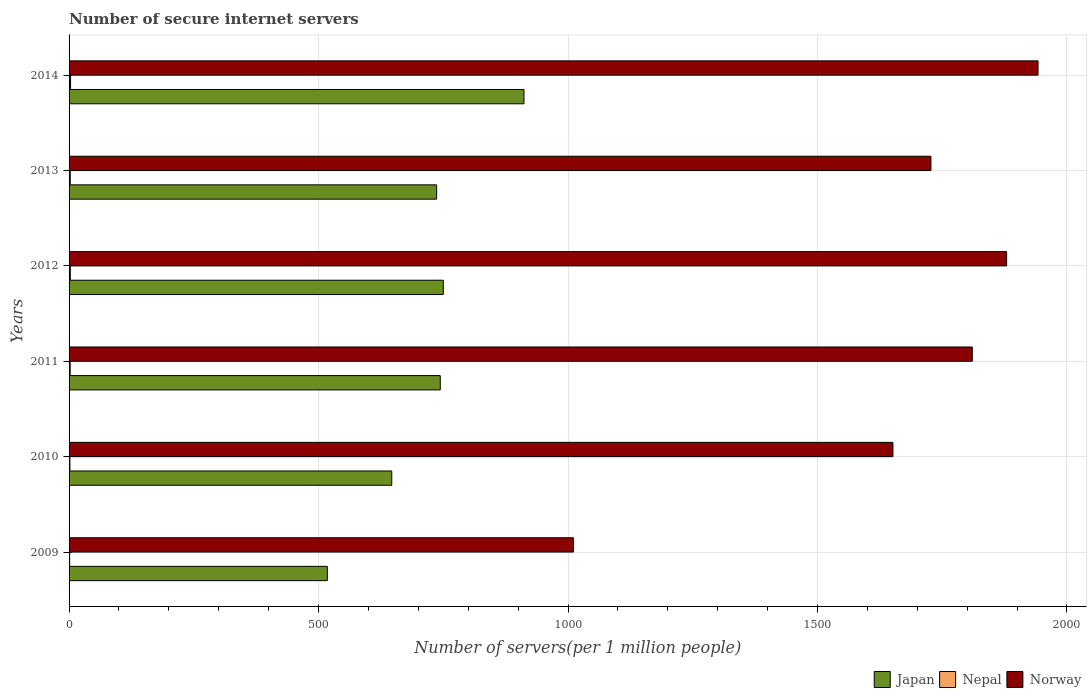Are the number of bars per tick equal to the number of legend labels?
Give a very brief answer. Yes. Are the number of bars on each tick of the Y-axis equal?
Provide a short and direct response. Yes. What is the label of the 3rd group of bars from the top?
Your response must be concise. 2012. What is the number of secure internet servers in Japan in 2012?
Give a very brief answer. 750.05. Across all years, what is the maximum number of secure internet servers in Norway?
Offer a terse response. 1941.99. Across all years, what is the minimum number of secure internet servers in Nepal?
Keep it short and to the point. 1.17. What is the total number of secure internet servers in Japan in the graph?
Your response must be concise. 4306.64. What is the difference between the number of secure internet servers in Nepal in 2009 and that in 2014?
Your answer should be very brief. -1.82. What is the difference between the number of secure internet servers in Norway in 2014 and the number of secure internet servers in Nepal in 2012?
Give a very brief answer. 1939.52. What is the average number of secure internet servers in Japan per year?
Keep it short and to the point. 717.77. In the year 2013, what is the difference between the number of secure internet servers in Norway and number of secure internet servers in Nepal?
Ensure brevity in your answer.  1724.92. What is the ratio of the number of secure internet servers in Nepal in 2013 to that in 2014?
Your answer should be compact. 0.8. Is the number of secure internet servers in Japan in 2009 less than that in 2010?
Your answer should be compact. Yes. Is the difference between the number of secure internet servers in Norway in 2009 and 2010 greater than the difference between the number of secure internet servers in Nepal in 2009 and 2010?
Your answer should be very brief. No. What is the difference between the highest and the second highest number of secure internet servers in Norway?
Make the answer very short. 62.97. What is the difference between the highest and the lowest number of secure internet servers in Nepal?
Your answer should be compact. 1.82. In how many years, is the number of secure internet servers in Japan greater than the average number of secure internet servers in Japan taken over all years?
Offer a very short reply. 4. What does the 2nd bar from the bottom in 2012 represents?
Give a very brief answer. Nepal. Is it the case that in every year, the sum of the number of secure internet servers in Norway and number of secure internet servers in Japan is greater than the number of secure internet servers in Nepal?
Your response must be concise. Yes. How many bars are there?
Your answer should be very brief. 18. Are all the bars in the graph horizontal?
Ensure brevity in your answer.  Yes. How many years are there in the graph?
Give a very brief answer. 6. Are the values on the major ticks of X-axis written in scientific E-notation?
Your response must be concise. No. Does the graph contain any zero values?
Make the answer very short. No. How are the legend labels stacked?
Provide a succinct answer. Horizontal. What is the title of the graph?
Give a very brief answer. Number of secure internet servers. Does "Trinidad and Tobago" appear as one of the legend labels in the graph?
Make the answer very short. No. What is the label or title of the X-axis?
Make the answer very short. Number of servers(per 1 million people). What is the label or title of the Y-axis?
Keep it short and to the point. Years. What is the Number of servers(per 1 million people) of Japan in 2009?
Give a very brief answer. 517.61. What is the Number of servers(per 1 million people) of Nepal in 2009?
Provide a succinct answer. 1.17. What is the Number of servers(per 1 million people) of Norway in 2009?
Your response must be concise. 1010.83. What is the Number of servers(per 1 million people) in Japan in 2010?
Ensure brevity in your answer.  646.7. What is the Number of servers(per 1 million people) of Nepal in 2010?
Ensure brevity in your answer.  1.67. What is the Number of servers(per 1 million people) of Norway in 2010?
Your answer should be compact. 1651.17. What is the Number of servers(per 1 million people) in Japan in 2011?
Make the answer very short. 743.93. What is the Number of servers(per 1 million people) in Nepal in 2011?
Your response must be concise. 2.17. What is the Number of servers(per 1 million people) in Norway in 2011?
Ensure brevity in your answer.  1810.18. What is the Number of servers(per 1 million people) in Japan in 2012?
Ensure brevity in your answer.  750.05. What is the Number of servers(per 1 million people) in Nepal in 2012?
Offer a terse response. 2.47. What is the Number of servers(per 1 million people) of Norway in 2012?
Your response must be concise. 1879.02. What is the Number of servers(per 1 million people) in Japan in 2013?
Provide a succinct answer. 736.67. What is the Number of servers(per 1 million people) of Nepal in 2013?
Your response must be concise. 2.37. What is the Number of servers(per 1 million people) in Norway in 2013?
Keep it short and to the point. 1727.29. What is the Number of servers(per 1 million people) in Japan in 2014?
Your answer should be compact. 911.68. What is the Number of servers(per 1 million people) of Nepal in 2014?
Give a very brief answer. 2.98. What is the Number of servers(per 1 million people) in Norway in 2014?
Offer a terse response. 1941.99. Across all years, what is the maximum Number of servers(per 1 million people) in Japan?
Provide a succinct answer. 911.68. Across all years, what is the maximum Number of servers(per 1 million people) in Nepal?
Offer a terse response. 2.98. Across all years, what is the maximum Number of servers(per 1 million people) of Norway?
Make the answer very short. 1941.99. Across all years, what is the minimum Number of servers(per 1 million people) of Japan?
Provide a succinct answer. 517.61. Across all years, what is the minimum Number of servers(per 1 million people) of Nepal?
Keep it short and to the point. 1.17. Across all years, what is the minimum Number of servers(per 1 million people) in Norway?
Keep it short and to the point. 1010.83. What is the total Number of servers(per 1 million people) of Japan in the graph?
Make the answer very short. 4306.64. What is the total Number of servers(per 1 million people) of Nepal in the graph?
Make the answer very short. 12.84. What is the total Number of servers(per 1 million people) of Norway in the graph?
Offer a terse response. 1.00e+04. What is the difference between the Number of servers(per 1 million people) of Japan in 2009 and that in 2010?
Offer a terse response. -129.09. What is the difference between the Number of servers(per 1 million people) in Nepal in 2009 and that in 2010?
Your answer should be very brief. -0.51. What is the difference between the Number of servers(per 1 million people) of Norway in 2009 and that in 2010?
Provide a short and direct response. -640.35. What is the difference between the Number of servers(per 1 million people) of Japan in 2009 and that in 2011?
Ensure brevity in your answer.  -226.31. What is the difference between the Number of servers(per 1 million people) of Nepal in 2009 and that in 2011?
Ensure brevity in your answer.  -1. What is the difference between the Number of servers(per 1 million people) of Norway in 2009 and that in 2011?
Offer a very short reply. -799.36. What is the difference between the Number of servers(per 1 million people) of Japan in 2009 and that in 2012?
Your response must be concise. -232.43. What is the difference between the Number of servers(per 1 million people) of Nepal in 2009 and that in 2012?
Make the answer very short. -1.31. What is the difference between the Number of servers(per 1 million people) in Norway in 2009 and that in 2012?
Ensure brevity in your answer.  -868.19. What is the difference between the Number of servers(per 1 million people) of Japan in 2009 and that in 2013?
Give a very brief answer. -219.05. What is the difference between the Number of servers(per 1 million people) in Nepal in 2009 and that in 2013?
Keep it short and to the point. -1.21. What is the difference between the Number of servers(per 1 million people) of Norway in 2009 and that in 2013?
Keep it short and to the point. -716.47. What is the difference between the Number of servers(per 1 million people) of Japan in 2009 and that in 2014?
Keep it short and to the point. -394.07. What is the difference between the Number of servers(per 1 million people) in Nepal in 2009 and that in 2014?
Keep it short and to the point. -1.82. What is the difference between the Number of servers(per 1 million people) in Norway in 2009 and that in 2014?
Offer a very short reply. -931.17. What is the difference between the Number of servers(per 1 million people) of Japan in 2010 and that in 2011?
Offer a very short reply. -97.23. What is the difference between the Number of servers(per 1 million people) of Nepal in 2010 and that in 2011?
Offer a terse response. -0.5. What is the difference between the Number of servers(per 1 million people) in Norway in 2010 and that in 2011?
Offer a very short reply. -159.01. What is the difference between the Number of servers(per 1 million people) in Japan in 2010 and that in 2012?
Provide a short and direct response. -103.35. What is the difference between the Number of servers(per 1 million people) of Nepal in 2010 and that in 2012?
Make the answer very short. -0.8. What is the difference between the Number of servers(per 1 million people) in Norway in 2010 and that in 2012?
Give a very brief answer. -227.85. What is the difference between the Number of servers(per 1 million people) of Japan in 2010 and that in 2013?
Provide a succinct answer. -89.96. What is the difference between the Number of servers(per 1 million people) in Nepal in 2010 and that in 2013?
Offer a terse response. -0.7. What is the difference between the Number of servers(per 1 million people) of Norway in 2010 and that in 2013?
Give a very brief answer. -76.12. What is the difference between the Number of servers(per 1 million people) of Japan in 2010 and that in 2014?
Provide a succinct answer. -264.98. What is the difference between the Number of servers(per 1 million people) in Nepal in 2010 and that in 2014?
Your answer should be compact. -1.31. What is the difference between the Number of servers(per 1 million people) of Norway in 2010 and that in 2014?
Give a very brief answer. -290.82. What is the difference between the Number of servers(per 1 million people) in Japan in 2011 and that in 2012?
Give a very brief answer. -6.12. What is the difference between the Number of servers(per 1 million people) in Nepal in 2011 and that in 2012?
Offer a terse response. -0.3. What is the difference between the Number of servers(per 1 million people) of Norway in 2011 and that in 2012?
Your answer should be compact. -68.84. What is the difference between the Number of servers(per 1 million people) of Japan in 2011 and that in 2013?
Offer a very short reply. 7.26. What is the difference between the Number of servers(per 1 million people) of Nepal in 2011 and that in 2013?
Offer a terse response. -0.2. What is the difference between the Number of servers(per 1 million people) of Norway in 2011 and that in 2013?
Your answer should be very brief. 82.89. What is the difference between the Number of servers(per 1 million people) of Japan in 2011 and that in 2014?
Make the answer very short. -167.75. What is the difference between the Number of servers(per 1 million people) of Nepal in 2011 and that in 2014?
Your answer should be very brief. -0.81. What is the difference between the Number of servers(per 1 million people) in Norway in 2011 and that in 2014?
Keep it short and to the point. -131.81. What is the difference between the Number of servers(per 1 million people) in Japan in 2012 and that in 2013?
Offer a terse response. 13.38. What is the difference between the Number of servers(per 1 million people) of Nepal in 2012 and that in 2013?
Make the answer very short. 0.1. What is the difference between the Number of servers(per 1 million people) in Norway in 2012 and that in 2013?
Give a very brief answer. 151.73. What is the difference between the Number of servers(per 1 million people) in Japan in 2012 and that in 2014?
Ensure brevity in your answer.  -161.64. What is the difference between the Number of servers(per 1 million people) in Nepal in 2012 and that in 2014?
Keep it short and to the point. -0.51. What is the difference between the Number of servers(per 1 million people) in Norway in 2012 and that in 2014?
Your response must be concise. -62.97. What is the difference between the Number of servers(per 1 million people) of Japan in 2013 and that in 2014?
Provide a short and direct response. -175.02. What is the difference between the Number of servers(per 1 million people) of Nepal in 2013 and that in 2014?
Provide a short and direct response. -0.61. What is the difference between the Number of servers(per 1 million people) of Norway in 2013 and that in 2014?
Make the answer very short. -214.7. What is the difference between the Number of servers(per 1 million people) of Japan in 2009 and the Number of servers(per 1 million people) of Nepal in 2010?
Provide a short and direct response. 515.94. What is the difference between the Number of servers(per 1 million people) of Japan in 2009 and the Number of servers(per 1 million people) of Norway in 2010?
Your answer should be compact. -1133.56. What is the difference between the Number of servers(per 1 million people) in Nepal in 2009 and the Number of servers(per 1 million people) in Norway in 2010?
Your answer should be compact. -1650.01. What is the difference between the Number of servers(per 1 million people) in Japan in 2009 and the Number of servers(per 1 million people) in Nepal in 2011?
Keep it short and to the point. 515.44. What is the difference between the Number of servers(per 1 million people) of Japan in 2009 and the Number of servers(per 1 million people) of Norway in 2011?
Your response must be concise. -1292.57. What is the difference between the Number of servers(per 1 million people) in Nepal in 2009 and the Number of servers(per 1 million people) in Norway in 2011?
Your response must be concise. -1809.02. What is the difference between the Number of servers(per 1 million people) in Japan in 2009 and the Number of servers(per 1 million people) in Nepal in 2012?
Give a very brief answer. 515.14. What is the difference between the Number of servers(per 1 million people) of Japan in 2009 and the Number of servers(per 1 million people) of Norway in 2012?
Ensure brevity in your answer.  -1361.41. What is the difference between the Number of servers(per 1 million people) in Nepal in 2009 and the Number of servers(per 1 million people) in Norway in 2012?
Ensure brevity in your answer.  -1877.85. What is the difference between the Number of servers(per 1 million people) of Japan in 2009 and the Number of servers(per 1 million people) of Nepal in 2013?
Keep it short and to the point. 515.24. What is the difference between the Number of servers(per 1 million people) of Japan in 2009 and the Number of servers(per 1 million people) of Norway in 2013?
Make the answer very short. -1209.68. What is the difference between the Number of servers(per 1 million people) of Nepal in 2009 and the Number of servers(per 1 million people) of Norway in 2013?
Keep it short and to the point. -1726.13. What is the difference between the Number of servers(per 1 million people) in Japan in 2009 and the Number of servers(per 1 million people) in Nepal in 2014?
Make the answer very short. 514.63. What is the difference between the Number of servers(per 1 million people) in Japan in 2009 and the Number of servers(per 1 million people) in Norway in 2014?
Provide a short and direct response. -1424.38. What is the difference between the Number of servers(per 1 million people) of Nepal in 2009 and the Number of servers(per 1 million people) of Norway in 2014?
Give a very brief answer. -1940.83. What is the difference between the Number of servers(per 1 million people) of Japan in 2010 and the Number of servers(per 1 million people) of Nepal in 2011?
Provide a short and direct response. 644.53. What is the difference between the Number of servers(per 1 million people) of Japan in 2010 and the Number of servers(per 1 million people) of Norway in 2011?
Provide a short and direct response. -1163.48. What is the difference between the Number of servers(per 1 million people) of Nepal in 2010 and the Number of servers(per 1 million people) of Norway in 2011?
Provide a succinct answer. -1808.51. What is the difference between the Number of servers(per 1 million people) in Japan in 2010 and the Number of servers(per 1 million people) in Nepal in 2012?
Your answer should be very brief. 644.23. What is the difference between the Number of servers(per 1 million people) in Japan in 2010 and the Number of servers(per 1 million people) in Norway in 2012?
Your answer should be compact. -1232.32. What is the difference between the Number of servers(per 1 million people) in Nepal in 2010 and the Number of servers(per 1 million people) in Norway in 2012?
Your answer should be compact. -1877.35. What is the difference between the Number of servers(per 1 million people) in Japan in 2010 and the Number of servers(per 1 million people) in Nepal in 2013?
Ensure brevity in your answer.  644.33. What is the difference between the Number of servers(per 1 million people) of Japan in 2010 and the Number of servers(per 1 million people) of Norway in 2013?
Provide a short and direct response. -1080.59. What is the difference between the Number of servers(per 1 million people) in Nepal in 2010 and the Number of servers(per 1 million people) in Norway in 2013?
Provide a short and direct response. -1725.62. What is the difference between the Number of servers(per 1 million people) of Japan in 2010 and the Number of servers(per 1 million people) of Nepal in 2014?
Provide a short and direct response. 643.72. What is the difference between the Number of servers(per 1 million people) in Japan in 2010 and the Number of servers(per 1 million people) in Norway in 2014?
Make the answer very short. -1295.29. What is the difference between the Number of servers(per 1 million people) of Nepal in 2010 and the Number of servers(per 1 million people) of Norway in 2014?
Offer a very short reply. -1940.32. What is the difference between the Number of servers(per 1 million people) in Japan in 2011 and the Number of servers(per 1 million people) in Nepal in 2012?
Provide a succinct answer. 741.46. What is the difference between the Number of servers(per 1 million people) of Japan in 2011 and the Number of servers(per 1 million people) of Norway in 2012?
Ensure brevity in your answer.  -1135.09. What is the difference between the Number of servers(per 1 million people) of Nepal in 2011 and the Number of servers(per 1 million people) of Norway in 2012?
Your response must be concise. -1876.85. What is the difference between the Number of servers(per 1 million people) of Japan in 2011 and the Number of servers(per 1 million people) of Nepal in 2013?
Give a very brief answer. 741.56. What is the difference between the Number of servers(per 1 million people) in Japan in 2011 and the Number of servers(per 1 million people) in Norway in 2013?
Offer a very short reply. -983.36. What is the difference between the Number of servers(per 1 million people) of Nepal in 2011 and the Number of servers(per 1 million people) of Norway in 2013?
Make the answer very short. -1725.12. What is the difference between the Number of servers(per 1 million people) in Japan in 2011 and the Number of servers(per 1 million people) in Nepal in 2014?
Ensure brevity in your answer.  740.95. What is the difference between the Number of servers(per 1 million people) of Japan in 2011 and the Number of servers(per 1 million people) of Norway in 2014?
Provide a short and direct response. -1198.06. What is the difference between the Number of servers(per 1 million people) in Nepal in 2011 and the Number of servers(per 1 million people) in Norway in 2014?
Ensure brevity in your answer.  -1939.82. What is the difference between the Number of servers(per 1 million people) of Japan in 2012 and the Number of servers(per 1 million people) of Nepal in 2013?
Make the answer very short. 747.67. What is the difference between the Number of servers(per 1 million people) of Japan in 2012 and the Number of servers(per 1 million people) of Norway in 2013?
Offer a very short reply. -977.25. What is the difference between the Number of servers(per 1 million people) of Nepal in 2012 and the Number of servers(per 1 million people) of Norway in 2013?
Give a very brief answer. -1724.82. What is the difference between the Number of servers(per 1 million people) in Japan in 2012 and the Number of servers(per 1 million people) in Nepal in 2014?
Offer a terse response. 747.06. What is the difference between the Number of servers(per 1 million people) of Japan in 2012 and the Number of servers(per 1 million people) of Norway in 2014?
Provide a succinct answer. -1191.95. What is the difference between the Number of servers(per 1 million people) of Nepal in 2012 and the Number of servers(per 1 million people) of Norway in 2014?
Offer a very short reply. -1939.52. What is the difference between the Number of servers(per 1 million people) of Japan in 2013 and the Number of servers(per 1 million people) of Nepal in 2014?
Your answer should be compact. 733.68. What is the difference between the Number of servers(per 1 million people) in Japan in 2013 and the Number of servers(per 1 million people) in Norway in 2014?
Offer a terse response. -1205.33. What is the difference between the Number of servers(per 1 million people) in Nepal in 2013 and the Number of servers(per 1 million people) in Norway in 2014?
Provide a succinct answer. -1939.62. What is the average Number of servers(per 1 million people) in Japan per year?
Offer a terse response. 717.77. What is the average Number of servers(per 1 million people) in Nepal per year?
Your response must be concise. 2.14. What is the average Number of servers(per 1 million people) in Norway per year?
Offer a very short reply. 1670.08. In the year 2009, what is the difference between the Number of servers(per 1 million people) of Japan and Number of servers(per 1 million people) of Nepal?
Offer a terse response. 516.45. In the year 2009, what is the difference between the Number of servers(per 1 million people) in Japan and Number of servers(per 1 million people) in Norway?
Offer a terse response. -493.21. In the year 2009, what is the difference between the Number of servers(per 1 million people) of Nepal and Number of servers(per 1 million people) of Norway?
Ensure brevity in your answer.  -1009.66. In the year 2010, what is the difference between the Number of servers(per 1 million people) in Japan and Number of servers(per 1 million people) in Nepal?
Offer a very short reply. 645.03. In the year 2010, what is the difference between the Number of servers(per 1 million people) in Japan and Number of servers(per 1 million people) in Norway?
Your answer should be very brief. -1004.47. In the year 2010, what is the difference between the Number of servers(per 1 million people) in Nepal and Number of servers(per 1 million people) in Norway?
Your answer should be very brief. -1649.5. In the year 2011, what is the difference between the Number of servers(per 1 million people) of Japan and Number of servers(per 1 million people) of Nepal?
Offer a terse response. 741.76. In the year 2011, what is the difference between the Number of servers(per 1 million people) of Japan and Number of servers(per 1 million people) of Norway?
Your answer should be compact. -1066.25. In the year 2011, what is the difference between the Number of servers(per 1 million people) in Nepal and Number of servers(per 1 million people) in Norway?
Give a very brief answer. -1808.01. In the year 2012, what is the difference between the Number of servers(per 1 million people) of Japan and Number of servers(per 1 million people) of Nepal?
Your answer should be very brief. 747.57. In the year 2012, what is the difference between the Number of servers(per 1 million people) in Japan and Number of servers(per 1 million people) in Norway?
Provide a short and direct response. -1128.97. In the year 2012, what is the difference between the Number of servers(per 1 million people) of Nepal and Number of servers(per 1 million people) of Norway?
Your answer should be compact. -1876.55. In the year 2013, what is the difference between the Number of servers(per 1 million people) of Japan and Number of servers(per 1 million people) of Nepal?
Your response must be concise. 734.29. In the year 2013, what is the difference between the Number of servers(per 1 million people) of Japan and Number of servers(per 1 million people) of Norway?
Provide a succinct answer. -990.63. In the year 2013, what is the difference between the Number of servers(per 1 million people) in Nepal and Number of servers(per 1 million people) in Norway?
Give a very brief answer. -1724.92. In the year 2014, what is the difference between the Number of servers(per 1 million people) in Japan and Number of servers(per 1 million people) in Nepal?
Give a very brief answer. 908.7. In the year 2014, what is the difference between the Number of servers(per 1 million people) in Japan and Number of servers(per 1 million people) in Norway?
Your answer should be very brief. -1030.31. In the year 2014, what is the difference between the Number of servers(per 1 million people) in Nepal and Number of servers(per 1 million people) in Norway?
Give a very brief answer. -1939.01. What is the ratio of the Number of servers(per 1 million people) in Japan in 2009 to that in 2010?
Your answer should be very brief. 0.8. What is the ratio of the Number of servers(per 1 million people) of Nepal in 2009 to that in 2010?
Ensure brevity in your answer.  0.7. What is the ratio of the Number of servers(per 1 million people) in Norway in 2009 to that in 2010?
Provide a succinct answer. 0.61. What is the ratio of the Number of servers(per 1 million people) in Japan in 2009 to that in 2011?
Make the answer very short. 0.7. What is the ratio of the Number of servers(per 1 million people) of Nepal in 2009 to that in 2011?
Give a very brief answer. 0.54. What is the ratio of the Number of servers(per 1 million people) in Norway in 2009 to that in 2011?
Offer a terse response. 0.56. What is the ratio of the Number of servers(per 1 million people) in Japan in 2009 to that in 2012?
Make the answer very short. 0.69. What is the ratio of the Number of servers(per 1 million people) in Nepal in 2009 to that in 2012?
Your answer should be very brief. 0.47. What is the ratio of the Number of servers(per 1 million people) of Norway in 2009 to that in 2012?
Make the answer very short. 0.54. What is the ratio of the Number of servers(per 1 million people) of Japan in 2009 to that in 2013?
Ensure brevity in your answer.  0.7. What is the ratio of the Number of servers(per 1 million people) of Nepal in 2009 to that in 2013?
Your answer should be very brief. 0.49. What is the ratio of the Number of servers(per 1 million people) of Norway in 2009 to that in 2013?
Ensure brevity in your answer.  0.59. What is the ratio of the Number of servers(per 1 million people) of Japan in 2009 to that in 2014?
Offer a very short reply. 0.57. What is the ratio of the Number of servers(per 1 million people) in Nepal in 2009 to that in 2014?
Offer a very short reply. 0.39. What is the ratio of the Number of servers(per 1 million people) of Norway in 2009 to that in 2014?
Your response must be concise. 0.52. What is the ratio of the Number of servers(per 1 million people) in Japan in 2010 to that in 2011?
Your response must be concise. 0.87. What is the ratio of the Number of servers(per 1 million people) in Nepal in 2010 to that in 2011?
Your answer should be compact. 0.77. What is the ratio of the Number of servers(per 1 million people) of Norway in 2010 to that in 2011?
Provide a succinct answer. 0.91. What is the ratio of the Number of servers(per 1 million people) of Japan in 2010 to that in 2012?
Make the answer very short. 0.86. What is the ratio of the Number of servers(per 1 million people) of Nepal in 2010 to that in 2012?
Make the answer very short. 0.68. What is the ratio of the Number of servers(per 1 million people) of Norway in 2010 to that in 2012?
Give a very brief answer. 0.88. What is the ratio of the Number of servers(per 1 million people) in Japan in 2010 to that in 2013?
Offer a terse response. 0.88. What is the ratio of the Number of servers(per 1 million people) of Nepal in 2010 to that in 2013?
Offer a very short reply. 0.71. What is the ratio of the Number of servers(per 1 million people) of Norway in 2010 to that in 2013?
Provide a short and direct response. 0.96. What is the ratio of the Number of servers(per 1 million people) of Japan in 2010 to that in 2014?
Give a very brief answer. 0.71. What is the ratio of the Number of servers(per 1 million people) of Nepal in 2010 to that in 2014?
Offer a very short reply. 0.56. What is the ratio of the Number of servers(per 1 million people) of Norway in 2010 to that in 2014?
Your answer should be compact. 0.85. What is the ratio of the Number of servers(per 1 million people) of Japan in 2011 to that in 2012?
Your answer should be very brief. 0.99. What is the ratio of the Number of servers(per 1 million people) in Nepal in 2011 to that in 2012?
Give a very brief answer. 0.88. What is the ratio of the Number of servers(per 1 million people) in Norway in 2011 to that in 2012?
Keep it short and to the point. 0.96. What is the ratio of the Number of servers(per 1 million people) of Japan in 2011 to that in 2013?
Your response must be concise. 1.01. What is the ratio of the Number of servers(per 1 million people) of Nepal in 2011 to that in 2013?
Your answer should be very brief. 0.92. What is the ratio of the Number of servers(per 1 million people) of Norway in 2011 to that in 2013?
Make the answer very short. 1.05. What is the ratio of the Number of servers(per 1 million people) of Japan in 2011 to that in 2014?
Give a very brief answer. 0.82. What is the ratio of the Number of servers(per 1 million people) in Nepal in 2011 to that in 2014?
Your response must be concise. 0.73. What is the ratio of the Number of servers(per 1 million people) of Norway in 2011 to that in 2014?
Your answer should be very brief. 0.93. What is the ratio of the Number of servers(per 1 million people) in Japan in 2012 to that in 2013?
Your response must be concise. 1.02. What is the ratio of the Number of servers(per 1 million people) in Nepal in 2012 to that in 2013?
Provide a succinct answer. 1.04. What is the ratio of the Number of servers(per 1 million people) in Norway in 2012 to that in 2013?
Ensure brevity in your answer.  1.09. What is the ratio of the Number of servers(per 1 million people) of Japan in 2012 to that in 2014?
Your answer should be compact. 0.82. What is the ratio of the Number of servers(per 1 million people) in Nepal in 2012 to that in 2014?
Ensure brevity in your answer.  0.83. What is the ratio of the Number of servers(per 1 million people) in Norway in 2012 to that in 2014?
Your answer should be very brief. 0.97. What is the ratio of the Number of servers(per 1 million people) in Japan in 2013 to that in 2014?
Provide a succinct answer. 0.81. What is the ratio of the Number of servers(per 1 million people) in Nepal in 2013 to that in 2014?
Your response must be concise. 0.8. What is the ratio of the Number of servers(per 1 million people) of Norway in 2013 to that in 2014?
Offer a very short reply. 0.89. What is the difference between the highest and the second highest Number of servers(per 1 million people) in Japan?
Your answer should be compact. 161.64. What is the difference between the highest and the second highest Number of servers(per 1 million people) of Nepal?
Ensure brevity in your answer.  0.51. What is the difference between the highest and the second highest Number of servers(per 1 million people) in Norway?
Give a very brief answer. 62.97. What is the difference between the highest and the lowest Number of servers(per 1 million people) in Japan?
Ensure brevity in your answer.  394.07. What is the difference between the highest and the lowest Number of servers(per 1 million people) in Nepal?
Offer a terse response. 1.82. What is the difference between the highest and the lowest Number of servers(per 1 million people) in Norway?
Your response must be concise. 931.17. 